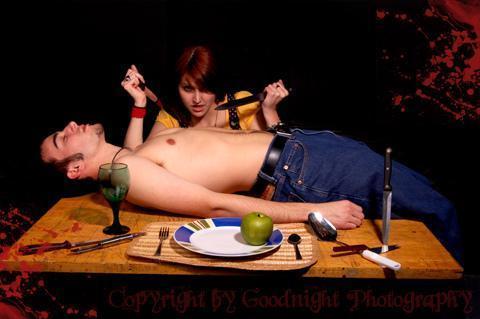How many knives are in the picture?
Give a very brief answer. 4. How many people are there?
Give a very brief answer. 2. How many green bottles are on the table?
Give a very brief answer. 0. 